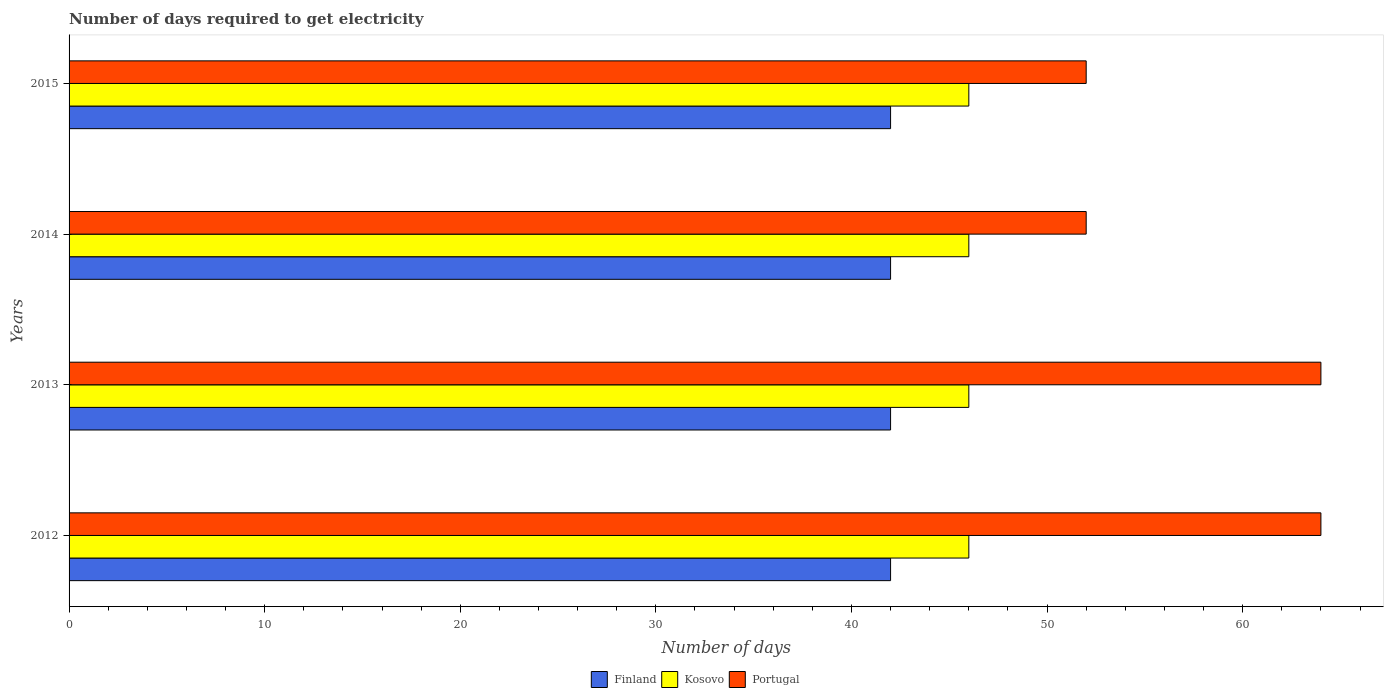How many different coloured bars are there?
Provide a succinct answer. 3. How many groups of bars are there?
Your answer should be very brief. 4. Are the number of bars per tick equal to the number of legend labels?
Offer a terse response. Yes. How many bars are there on the 3rd tick from the bottom?
Offer a terse response. 3. What is the label of the 3rd group of bars from the top?
Offer a terse response. 2013. What is the number of days required to get electricity in in Portugal in 2012?
Offer a terse response. 64. Across all years, what is the maximum number of days required to get electricity in in Finland?
Make the answer very short. 42. Across all years, what is the minimum number of days required to get electricity in in Finland?
Provide a succinct answer. 42. In which year was the number of days required to get electricity in in Portugal maximum?
Offer a terse response. 2012. What is the total number of days required to get electricity in in Finland in the graph?
Provide a succinct answer. 168. What is the difference between the number of days required to get electricity in in Kosovo in 2014 and the number of days required to get electricity in in Finland in 2013?
Provide a short and direct response. 4. What is the average number of days required to get electricity in in Finland per year?
Your response must be concise. 42. In the year 2012, what is the difference between the number of days required to get electricity in in Portugal and number of days required to get electricity in in Kosovo?
Provide a succinct answer. 18. In how many years, is the number of days required to get electricity in in Kosovo greater than 16 days?
Your response must be concise. 4. What is the difference between the highest and the lowest number of days required to get electricity in in Kosovo?
Make the answer very short. 0. What does the 3rd bar from the top in 2015 represents?
Give a very brief answer. Finland. What does the 2nd bar from the bottom in 2012 represents?
Give a very brief answer. Kosovo. Is it the case that in every year, the sum of the number of days required to get electricity in in Kosovo and number of days required to get electricity in in Portugal is greater than the number of days required to get electricity in in Finland?
Offer a terse response. Yes. How many bars are there?
Keep it short and to the point. 12. Are all the bars in the graph horizontal?
Ensure brevity in your answer.  Yes. Are the values on the major ticks of X-axis written in scientific E-notation?
Keep it short and to the point. No. How many legend labels are there?
Provide a succinct answer. 3. How are the legend labels stacked?
Your answer should be very brief. Horizontal. What is the title of the graph?
Your answer should be very brief. Number of days required to get electricity. Does "Morocco" appear as one of the legend labels in the graph?
Provide a succinct answer. No. What is the label or title of the X-axis?
Keep it short and to the point. Number of days. What is the label or title of the Y-axis?
Provide a succinct answer. Years. What is the Number of days of Finland in 2012?
Provide a short and direct response. 42. What is the Number of days of Kosovo in 2012?
Make the answer very short. 46. What is the Number of days of Portugal in 2012?
Offer a very short reply. 64. What is the Number of days of Finland in 2013?
Ensure brevity in your answer.  42. What is the Number of days of Kosovo in 2013?
Ensure brevity in your answer.  46. What is the Number of days in Finland in 2014?
Your answer should be very brief. 42. What is the Number of days in Portugal in 2014?
Provide a succinct answer. 52. What is the Number of days in Finland in 2015?
Give a very brief answer. 42. What is the Number of days of Kosovo in 2015?
Provide a short and direct response. 46. What is the Number of days of Portugal in 2015?
Ensure brevity in your answer.  52. Across all years, what is the minimum Number of days in Portugal?
Make the answer very short. 52. What is the total Number of days in Finland in the graph?
Offer a very short reply. 168. What is the total Number of days of Kosovo in the graph?
Offer a very short reply. 184. What is the total Number of days of Portugal in the graph?
Your answer should be compact. 232. What is the difference between the Number of days in Finland in 2012 and that in 2014?
Your response must be concise. 0. What is the difference between the Number of days in Kosovo in 2012 and that in 2014?
Provide a succinct answer. 0. What is the difference between the Number of days in Portugal in 2012 and that in 2014?
Offer a terse response. 12. What is the difference between the Number of days in Finland in 2012 and that in 2015?
Provide a short and direct response. 0. What is the difference between the Number of days in Portugal in 2012 and that in 2015?
Provide a short and direct response. 12. What is the difference between the Number of days in Portugal in 2013 and that in 2014?
Your answer should be very brief. 12. What is the difference between the Number of days in Portugal in 2013 and that in 2015?
Your response must be concise. 12. What is the difference between the Number of days of Finland in 2014 and that in 2015?
Provide a short and direct response. 0. What is the difference between the Number of days in Finland in 2012 and the Number of days in Kosovo in 2013?
Ensure brevity in your answer.  -4. What is the difference between the Number of days in Finland in 2012 and the Number of days in Kosovo in 2014?
Your response must be concise. -4. What is the difference between the Number of days in Kosovo in 2012 and the Number of days in Portugal in 2014?
Ensure brevity in your answer.  -6. What is the difference between the Number of days of Finland in 2012 and the Number of days of Kosovo in 2015?
Provide a short and direct response. -4. What is the difference between the Number of days of Finland in 2012 and the Number of days of Portugal in 2015?
Your response must be concise. -10. What is the difference between the Number of days of Finland in 2013 and the Number of days of Kosovo in 2014?
Give a very brief answer. -4. What is the difference between the Number of days of Kosovo in 2013 and the Number of days of Portugal in 2014?
Provide a short and direct response. -6. What is the difference between the Number of days in Finland in 2013 and the Number of days in Portugal in 2015?
Provide a short and direct response. -10. What is the difference between the Number of days in Finland in 2014 and the Number of days in Portugal in 2015?
Offer a terse response. -10. What is the average Number of days in Finland per year?
Give a very brief answer. 42. What is the average Number of days in Portugal per year?
Provide a succinct answer. 58. In the year 2012, what is the difference between the Number of days of Finland and Number of days of Portugal?
Offer a terse response. -22. In the year 2013, what is the difference between the Number of days in Finland and Number of days in Kosovo?
Keep it short and to the point. -4. In the year 2013, what is the difference between the Number of days of Finland and Number of days of Portugal?
Give a very brief answer. -22. In the year 2013, what is the difference between the Number of days in Kosovo and Number of days in Portugal?
Your answer should be very brief. -18. In the year 2014, what is the difference between the Number of days in Kosovo and Number of days in Portugal?
Make the answer very short. -6. In the year 2015, what is the difference between the Number of days in Finland and Number of days in Kosovo?
Your answer should be compact. -4. In the year 2015, what is the difference between the Number of days in Finland and Number of days in Portugal?
Provide a succinct answer. -10. In the year 2015, what is the difference between the Number of days in Kosovo and Number of days in Portugal?
Provide a short and direct response. -6. What is the ratio of the Number of days of Kosovo in 2012 to that in 2013?
Offer a terse response. 1. What is the ratio of the Number of days of Portugal in 2012 to that in 2013?
Give a very brief answer. 1. What is the ratio of the Number of days of Portugal in 2012 to that in 2014?
Ensure brevity in your answer.  1.23. What is the ratio of the Number of days of Kosovo in 2012 to that in 2015?
Offer a very short reply. 1. What is the ratio of the Number of days of Portugal in 2012 to that in 2015?
Give a very brief answer. 1.23. What is the ratio of the Number of days of Kosovo in 2013 to that in 2014?
Provide a short and direct response. 1. What is the ratio of the Number of days of Portugal in 2013 to that in 2014?
Provide a succinct answer. 1.23. What is the ratio of the Number of days of Finland in 2013 to that in 2015?
Offer a terse response. 1. What is the ratio of the Number of days in Kosovo in 2013 to that in 2015?
Offer a terse response. 1. What is the ratio of the Number of days in Portugal in 2013 to that in 2015?
Your response must be concise. 1.23. What is the ratio of the Number of days of Kosovo in 2014 to that in 2015?
Keep it short and to the point. 1. What is the ratio of the Number of days of Portugal in 2014 to that in 2015?
Provide a succinct answer. 1. What is the difference between the highest and the lowest Number of days in Finland?
Provide a short and direct response. 0. 